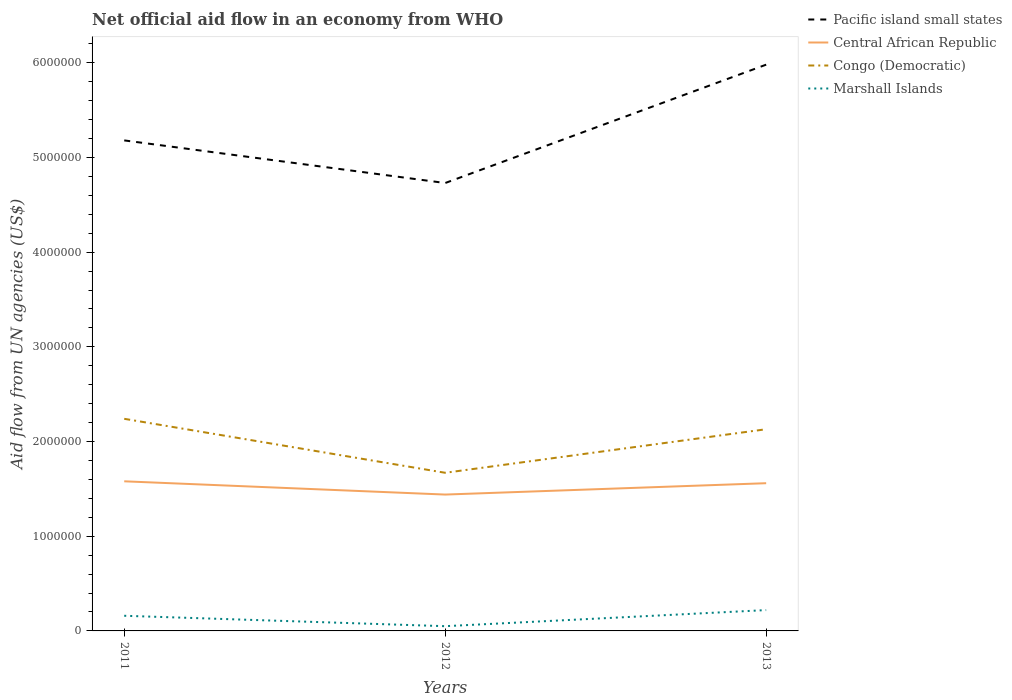Is the number of lines equal to the number of legend labels?
Keep it short and to the point. Yes. Across all years, what is the maximum net official aid flow in Central African Republic?
Give a very brief answer. 1.44e+06. In which year was the net official aid flow in Congo (Democratic) maximum?
Offer a very short reply. 2012. What is the total net official aid flow in Marshall Islands in the graph?
Your answer should be compact. -1.70e+05. What is the difference between the highest and the lowest net official aid flow in Central African Republic?
Offer a very short reply. 2. Is the net official aid flow in Pacific island small states strictly greater than the net official aid flow in Congo (Democratic) over the years?
Make the answer very short. No. How many lines are there?
Keep it short and to the point. 4. What is the difference between two consecutive major ticks on the Y-axis?
Ensure brevity in your answer.  1.00e+06. Are the values on the major ticks of Y-axis written in scientific E-notation?
Keep it short and to the point. No. Does the graph contain any zero values?
Make the answer very short. No. How are the legend labels stacked?
Give a very brief answer. Vertical. What is the title of the graph?
Your answer should be very brief. Net official aid flow in an economy from WHO. Does "Cyprus" appear as one of the legend labels in the graph?
Make the answer very short. No. What is the label or title of the X-axis?
Your response must be concise. Years. What is the label or title of the Y-axis?
Your response must be concise. Aid flow from UN agencies (US$). What is the Aid flow from UN agencies (US$) of Pacific island small states in 2011?
Make the answer very short. 5.18e+06. What is the Aid flow from UN agencies (US$) of Central African Republic in 2011?
Provide a succinct answer. 1.58e+06. What is the Aid flow from UN agencies (US$) in Congo (Democratic) in 2011?
Your response must be concise. 2.24e+06. What is the Aid flow from UN agencies (US$) in Marshall Islands in 2011?
Provide a succinct answer. 1.60e+05. What is the Aid flow from UN agencies (US$) of Pacific island small states in 2012?
Your answer should be compact. 4.73e+06. What is the Aid flow from UN agencies (US$) in Central African Republic in 2012?
Offer a terse response. 1.44e+06. What is the Aid flow from UN agencies (US$) in Congo (Democratic) in 2012?
Make the answer very short. 1.67e+06. What is the Aid flow from UN agencies (US$) in Pacific island small states in 2013?
Give a very brief answer. 5.98e+06. What is the Aid flow from UN agencies (US$) in Central African Republic in 2013?
Your answer should be very brief. 1.56e+06. What is the Aid flow from UN agencies (US$) of Congo (Democratic) in 2013?
Ensure brevity in your answer.  2.13e+06. What is the Aid flow from UN agencies (US$) in Marshall Islands in 2013?
Keep it short and to the point. 2.20e+05. Across all years, what is the maximum Aid flow from UN agencies (US$) of Pacific island small states?
Your answer should be compact. 5.98e+06. Across all years, what is the maximum Aid flow from UN agencies (US$) in Central African Republic?
Offer a very short reply. 1.58e+06. Across all years, what is the maximum Aid flow from UN agencies (US$) in Congo (Democratic)?
Your answer should be very brief. 2.24e+06. Across all years, what is the maximum Aid flow from UN agencies (US$) of Marshall Islands?
Give a very brief answer. 2.20e+05. Across all years, what is the minimum Aid flow from UN agencies (US$) in Pacific island small states?
Your answer should be very brief. 4.73e+06. Across all years, what is the minimum Aid flow from UN agencies (US$) in Central African Republic?
Ensure brevity in your answer.  1.44e+06. Across all years, what is the minimum Aid flow from UN agencies (US$) of Congo (Democratic)?
Your answer should be very brief. 1.67e+06. Across all years, what is the minimum Aid flow from UN agencies (US$) of Marshall Islands?
Make the answer very short. 5.00e+04. What is the total Aid flow from UN agencies (US$) in Pacific island small states in the graph?
Ensure brevity in your answer.  1.59e+07. What is the total Aid flow from UN agencies (US$) in Central African Republic in the graph?
Your answer should be very brief. 4.58e+06. What is the total Aid flow from UN agencies (US$) in Congo (Democratic) in the graph?
Your answer should be very brief. 6.04e+06. What is the total Aid flow from UN agencies (US$) of Marshall Islands in the graph?
Provide a succinct answer. 4.30e+05. What is the difference between the Aid flow from UN agencies (US$) of Congo (Democratic) in 2011 and that in 2012?
Ensure brevity in your answer.  5.70e+05. What is the difference between the Aid flow from UN agencies (US$) in Pacific island small states in 2011 and that in 2013?
Offer a terse response. -8.00e+05. What is the difference between the Aid flow from UN agencies (US$) of Central African Republic in 2011 and that in 2013?
Keep it short and to the point. 2.00e+04. What is the difference between the Aid flow from UN agencies (US$) in Marshall Islands in 2011 and that in 2013?
Keep it short and to the point. -6.00e+04. What is the difference between the Aid flow from UN agencies (US$) in Pacific island small states in 2012 and that in 2013?
Your response must be concise. -1.25e+06. What is the difference between the Aid flow from UN agencies (US$) of Central African Republic in 2012 and that in 2013?
Your answer should be very brief. -1.20e+05. What is the difference between the Aid flow from UN agencies (US$) of Congo (Democratic) in 2012 and that in 2013?
Offer a very short reply. -4.60e+05. What is the difference between the Aid flow from UN agencies (US$) in Marshall Islands in 2012 and that in 2013?
Offer a very short reply. -1.70e+05. What is the difference between the Aid flow from UN agencies (US$) in Pacific island small states in 2011 and the Aid flow from UN agencies (US$) in Central African Republic in 2012?
Ensure brevity in your answer.  3.74e+06. What is the difference between the Aid flow from UN agencies (US$) of Pacific island small states in 2011 and the Aid flow from UN agencies (US$) of Congo (Democratic) in 2012?
Your response must be concise. 3.51e+06. What is the difference between the Aid flow from UN agencies (US$) of Pacific island small states in 2011 and the Aid flow from UN agencies (US$) of Marshall Islands in 2012?
Your answer should be very brief. 5.13e+06. What is the difference between the Aid flow from UN agencies (US$) of Central African Republic in 2011 and the Aid flow from UN agencies (US$) of Congo (Democratic) in 2012?
Provide a succinct answer. -9.00e+04. What is the difference between the Aid flow from UN agencies (US$) in Central African Republic in 2011 and the Aid flow from UN agencies (US$) in Marshall Islands in 2012?
Give a very brief answer. 1.53e+06. What is the difference between the Aid flow from UN agencies (US$) in Congo (Democratic) in 2011 and the Aid flow from UN agencies (US$) in Marshall Islands in 2012?
Offer a very short reply. 2.19e+06. What is the difference between the Aid flow from UN agencies (US$) in Pacific island small states in 2011 and the Aid flow from UN agencies (US$) in Central African Republic in 2013?
Offer a terse response. 3.62e+06. What is the difference between the Aid flow from UN agencies (US$) in Pacific island small states in 2011 and the Aid flow from UN agencies (US$) in Congo (Democratic) in 2013?
Your answer should be compact. 3.05e+06. What is the difference between the Aid flow from UN agencies (US$) in Pacific island small states in 2011 and the Aid flow from UN agencies (US$) in Marshall Islands in 2013?
Provide a succinct answer. 4.96e+06. What is the difference between the Aid flow from UN agencies (US$) of Central African Republic in 2011 and the Aid flow from UN agencies (US$) of Congo (Democratic) in 2013?
Keep it short and to the point. -5.50e+05. What is the difference between the Aid flow from UN agencies (US$) of Central African Republic in 2011 and the Aid flow from UN agencies (US$) of Marshall Islands in 2013?
Offer a very short reply. 1.36e+06. What is the difference between the Aid flow from UN agencies (US$) of Congo (Democratic) in 2011 and the Aid flow from UN agencies (US$) of Marshall Islands in 2013?
Offer a terse response. 2.02e+06. What is the difference between the Aid flow from UN agencies (US$) in Pacific island small states in 2012 and the Aid flow from UN agencies (US$) in Central African Republic in 2013?
Make the answer very short. 3.17e+06. What is the difference between the Aid flow from UN agencies (US$) of Pacific island small states in 2012 and the Aid flow from UN agencies (US$) of Congo (Democratic) in 2013?
Give a very brief answer. 2.60e+06. What is the difference between the Aid flow from UN agencies (US$) of Pacific island small states in 2012 and the Aid flow from UN agencies (US$) of Marshall Islands in 2013?
Your answer should be very brief. 4.51e+06. What is the difference between the Aid flow from UN agencies (US$) in Central African Republic in 2012 and the Aid flow from UN agencies (US$) in Congo (Democratic) in 2013?
Your answer should be compact. -6.90e+05. What is the difference between the Aid flow from UN agencies (US$) of Central African Republic in 2012 and the Aid flow from UN agencies (US$) of Marshall Islands in 2013?
Give a very brief answer. 1.22e+06. What is the difference between the Aid flow from UN agencies (US$) of Congo (Democratic) in 2012 and the Aid flow from UN agencies (US$) of Marshall Islands in 2013?
Your response must be concise. 1.45e+06. What is the average Aid flow from UN agencies (US$) of Pacific island small states per year?
Provide a succinct answer. 5.30e+06. What is the average Aid flow from UN agencies (US$) in Central African Republic per year?
Offer a terse response. 1.53e+06. What is the average Aid flow from UN agencies (US$) of Congo (Democratic) per year?
Provide a short and direct response. 2.01e+06. What is the average Aid flow from UN agencies (US$) of Marshall Islands per year?
Give a very brief answer. 1.43e+05. In the year 2011, what is the difference between the Aid flow from UN agencies (US$) in Pacific island small states and Aid flow from UN agencies (US$) in Central African Republic?
Give a very brief answer. 3.60e+06. In the year 2011, what is the difference between the Aid flow from UN agencies (US$) in Pacific island small states and Aid flow from UN agencies (US$) in Congo (Democratic)?
Provide a succinct answer. 2.94e+06. In the year 2011, what is the difference between the Aid flow from UN agencies (US$) of Pacific island small states and Aid flow from UN agencies (US$) of Marshall Islands?
Your response must be concise. 5.02e+06. In the year 2011, what is the difference between the Aid flow from UN agencies (US$) of Central African Republic and Aid flow from UN agencies (US$) of Congo (Democratic)?
Keep it short and to the point. -6.60e+05. In the year 2011, what is the difference between the Aid flow from UN agencies (US$) in Central African Republic and Aid flow from UN agencies (US$) in Marshall Islands?
Offer a terse response. 1.42e+06. In the year 2011, what is the difference between the Aid flow from UN agencies (US$) of Congo (Democratic) and Aid flow from UN agencies (US$) of Marshall Islands?
Provide a short and direct response. 2.08e+06. In the year 2012, what is the difference between the Aid flow from UN agencies (US$) in Pacific island small states and Aid flow from UN agencies (US$) in Central African Republic?
Give a very brief answer. 3.29e+06. In the year 2012, what is the difference between the Aid flow from UN agencies (US$) in Pacific island small states and Aid flow from UN agencies (US$) in Congo (Democratic)?
Your response must be concise. 3.06e+06. In the year 2012, what is the difference between the Aid flow from UN agencies (US$) in Pacific island small states and Aid flow from UN agencies (US$) in Marshall Islands?
Ensure brevity in your answer.  4.68e+06. In the year 2012, what is the difference between the Aid flow from UN agencies (US$) in Central African Republic and Aid flow from UN agencies (US$) in Congo (Democratic)?
Offer a terse response. -2.30e+05. In the year 2012, what is the difference between the Aid flow from UN agencies (US$) in Central African Republic and Aid flow from UN agencies (US$) in Marshall Islands?
Give a very brief answer. 1.39e+06. In the year 2012, what is the difference between the Aid flow from UN agencies (US$) of Congo (Democratic) and Aid flow from UN agencies (US$) of Marshall Islands?
Make the answer very short. 1.62e+06. In the year 2013, what is the difference between the Aid flow from UN agencies (US$) in Pacific island small states and Aid flow from UN agencies (US$) in Central African Republic?
Give a very brief answer. 4.42e+06. In the year 2013, what is the difference between the Aid flow from UN agencies (US$) of Pacific island small states and Aid flow from UN agencies (US$) of Congo (Democratic)?
Your answer should be very brief. 3.85e+06. In the year 2013, what is the difference between the Aid flow from UN agencies (US$) of Pacific island small states and Aid flow from UN agencies (US$) of Marshall Islands?
Offer a terse response. 5.76e+06. In the year 2013, what is the difference between the Aid flow from UN agencies (US$) in Central African Republic and Aid flow from UN agencies (US$) in Congo (Democratic)?
Keep it short and to the point. -5.70e+05. In the year 2013, what is the difference between the Aid flow from UN agencies (US$) in Central African Republic and Aid flow from UN agencies (US$) in Marshall Islands?
Your response must be concise. 1.34e+06. In the year 2013, what is the difference between the Aid flow from UN agencies (US$) of Congo (Democratic) and Aid flow from UN agencies (US$) of Marshall Islands?
Give a very brief answer. 1.91e+06. What is the ratio of the Aid flow from UN agencies (US$) in Pacific island small states in 2011 to that in 2012?
Keep it short and to the point. 1.1. What is the ratio of the Aid flow from UN agencies (US$) in Central African Republic in 2011 to that in 2012?
Give a very brief answer. 1.1. What is the ratio of the Aid flow from UN agencies (US$) of Congo (Democratic) in 2011 to that in 2012?
Your response must be concise. 1.34. What is the ratio of the Aid flow from UN agencies (US$) in Pacific island small states in 2011 to that in 2013?
Offer a terse response. 0.87. What is the ratio of the Aid flow from UN agencies (US$) in Central African Republic in 2011 to that in 2013?
Your answer should be very brief. 1.01. What is the ratio of the Aid flow from UN agencies (US$) of Congo (Democratic) in 2011 to that in 2013?
Ensure brevity in your answer.  1.05. What is the ratio of the Aid flow from UN agencies (US$) of Marshall Islands in 2011 to that in 2013?
Provide a succinct answer. 0.73. What is the ratio of the Aid flow from UN agencies (US$) in Pacific island small states in 2012 to that in 2013?
Make the answer very short. 0.79. What is the ratio of the Aid flow from UN agencies (US$) of Congo (Democratic) in 2012 to that in 2013?
Make the answer very short. 0.78. What is the ratio of the Aid flow from UN agencies (US$) of Marshall Islands in 2012 to that in 2013?
Your answer should be very brief. 0.23. What is the difference between the highest and the second highest Aid flow from UN agencies (US$) in Central African Republic?
Offer a terse response. 2.00e+04. What is the difference between the highest and the second highest Aid flow from UN agencies (US$) in Congo (Democratic)?
Make the answer very short. 1.10e+05. What is the difference between the highest and the lowest Aid flow from UN agencies (US$) of Pacific island small states?
Your answer should be very brief. 1.25e+06. What is the difference between the highest and the lowest Aid flow from UN agencies (US$) in Congo (Democratic)?
Your answer should be compact. 5.70e+05. What is the difference between the highest and the lowest Aid flow from UN agencies (US$) in Marshall Islands?
Ensure brevity in your answer.  1.70e+05. 